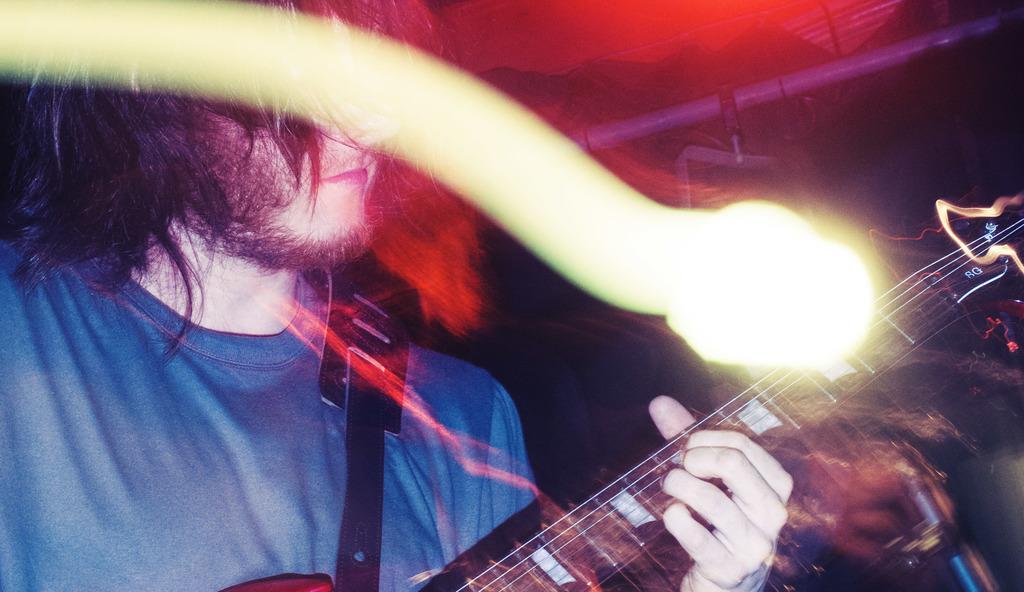Could you give a brief overview of what you see in this image? In this picture there is a boy who is standing at the left side of the image, by holding the guitar in his hands, and there are spotlights above the stage at the right side of the image. 